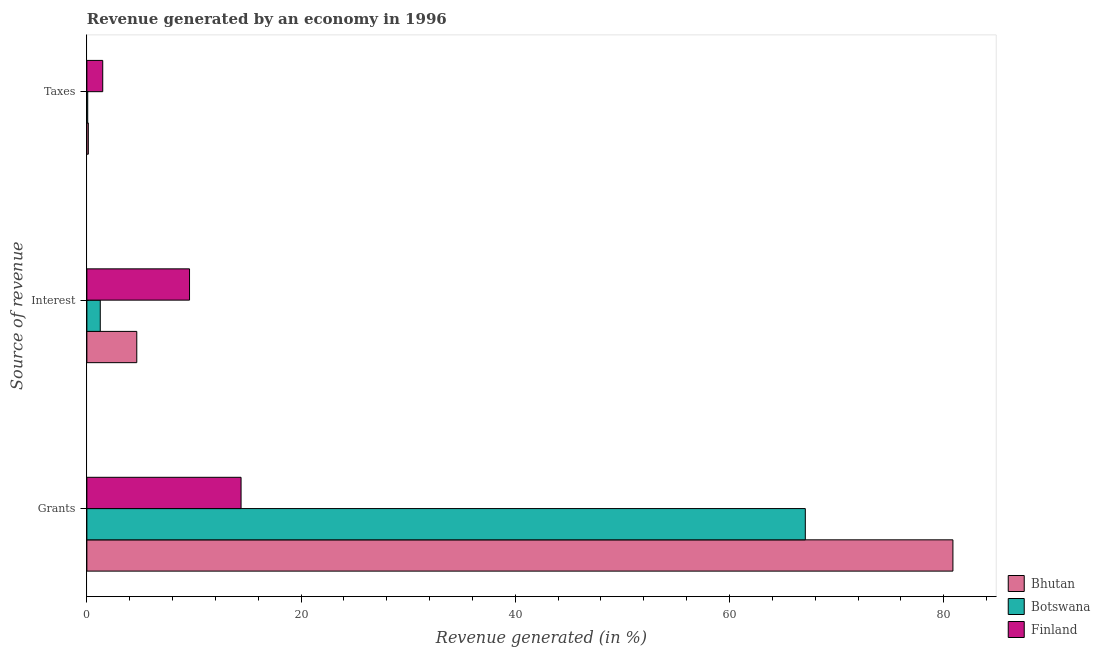How many different coloured bars are there?
Provide a succinct answer. 3. How many groups of bars are there?
Provide a succinct answer. 3. Are the number of bars per tick equal to the number of legend labels?
Your answer should be compact. Yes. How many bars are there on the 3rd tick from the top?
Ensure brevity in your answer.  3. What is the label of the 1st group of bars from the top?
Provide a short and direct response. Taxes. What is the percentage of revenue generated by taxes in Bhutan?
Your response must be concise. 0.14. Across all countries, what is the maximum percentage of revenue generated by taxes?
Your answer should be very brief. 1.48. Across all countries, what is the minimum percentage of revenue generated by taxes?
Provide a short and direct response. 0.08. In which country was the percentage of revenue generated by interest minimum?
Your answer should be compact. Botswana. What is the total percentage of revenue generated by grants in the graph?
Provide a succinct answer. 162.33. What is the difference between the percentage of revenue generated by interest in Finland and that in Bhutan?
Your answer should be compact. 4.92. What is the difference between the percentage of revenue generated by interest in Bhutan and the percentage of revenue generated by taxes in Finland?
Your response must be concise. 3.18. What is the average percentage of revenue generated by grants per country?
Your answer should be compact. 54.11. What is the difference between the percentage of revenue generated by taxes and percentage of revenue generated by grants in Bhutan?
Ensure brevity in your answer.  -80.72. In how many countries, is the percentage of revenue generated by grants greater than 36 %?
Provide a short and direct response. 2. What is the ratio of the percentage of revenue generated by taxes in Finland to that in Bhutan?
Give a very brief answer. 10.89. Is the percentage of revenue generated by interest in Finland less than that in Botswana?
Your response must be concise. No. Is the difference between the percentage of revenue generated by taxes in Bhutan and Finland greater than the difference between the percentage of revenue generated by grants in Bhutan and Finland?
Give a very brief answer. No. What is the difference between the highest and the second highest percentage of revenue generated by interest?
Provide a succinct answer. 4.92. What is the difference between the highest and the lowest percentage of revenue generated by interest?
Keep it short and to the point. 8.33. Is the sum of the percentage of revenue generated by taxes in Finland and Botswana greater than the maximum percentage of revenue generated by grants across all countries?
Your response must be concise. No. What does the 3rd bar from the top in Interest represents?
Offer a very short reply. Bhutan. What does the 3rd bar from the bottom in Taxes represents?
Keep it short and to the point. Finland. How many bars are there?
Your answer should be very brief. 9. Are all the bars in the graph horizontal?
Provide a succinct answer. Yes. How many countries are there in the graph?
Ensure brevity in your answer.  3. Does the graph contain any zero values?
Offer a very short reply. No. How many legend labels are there?
Your answer should be compact. 3. How are the legend labels stacked?
Keep it short and to the point. Vertical. What is the title of the graph?
Your answer should be compact. Revenue generated by an economy in 1996. Does "Least developed countries" appear as one of the legend labels in the graph?
Your answer should be compact. No. What is the label or title of the X-axis?
Provide a short and direct response. Revenue generated (in %). What is the label or title of the Y-axis?
Provide a succinct answer. Source of revenue. What is the Revenue generated (in %) in Bhutan in Grants?
Your answer should be very brief. 80.86. What is the Revenue generated (in %) in Botswana in Grants?
Your response must be concise. 67.08. What is the Revenue generated (in %) of Finland in Grants?
Your response must be concise. 14.4. What is the Revenue generated (in %) of Bhutan in Interest?
Offer a terse response. 4.66. What is the Revenue generated (in %) of Botswana in Interest?
Provide a succinct answer. 1.25. What is the Revenue generated (in %) in Finland in Interest?
Offer a terse response. 9.58. What is the Revenue generated (in %) of Bhutan in Taxes?
Provide a short and direct response. 0.14. What is the Revenue generated (in %) in Botswana in Taxes?
Provide a succinct answer. 0.08. What is the Revenue generated (in %) of Finland in Taxes?
Your answer should be very brief. 1.48. Across all Source of revenue, what is the maximum Revenue generated (in %) of Bhutan?
Provide a succinct answer. 80.86. Across all Source of revenue, what is the maximum Revenue generated (in %) in Botswana?
Give a very brief answer. 67.08. Across all Source of revenue, what is the maximum Revenue generated (in %) of Finland?
Your answer should be very brief. 14.4. Across all Source of revenue, what is the minimum Revenue generated (in %) in Bhutan?
Give a very brief answer. 0.14. Across all Source of revenue, what is the minimum Revenue generated (in %) of Botswana?
Your response must be concise. 0.08. Across all Source of revenue, what is the minimum Revenue generated (in %) in Finland?
Give a very brief answer. 1.48. What is the total Revenue generated (in %) in Bhutan in the graph?
Provide a short and direct response. 85.65. What is the total Revenue generated (in %) in Botswana in the graph?
Ensure brevity in your answer.  68.4. What is the total Revenue generated (in %) of Finland in the graph?
Give a very brief answer. 25.46. What is the difference between the Revenue generated (in %) in Bhutan in Grants and that in Interest?
Keep it short and to the point. 76.2. What is the difference between the Revenue generated (in %) in Botswana in Grants and that in Interest?
Keep it short and to the point. 65.83. What is the difference between the Revenue generated (in %) in Finland in Grants and that in Interest?
Provide a short and direct response. 4.81. What is the difference between the Revenue generated (in %) in Bhutan in Grants and that in Taxes?
Offer a very short reply. 80.72. What is the difference between the Revenue generated (in %) in Botswana in Grants and that in Taxes?
Offer a very short reply. 67. What is the difference between the Revenue generated (in %) in Finland in Grants and that in Taxes?
Offer a very short reply. 12.91. What is the difference between the Revenue generated (in %) in Bhutan in Interest and that in Taxes?
Make the answer very short. 4.52. What is the difference between the Revenue generated (in %) of Botswana in Interest and that in Taxes?
Offer a terse response. 1.17. What is the difference between the Revenue generated (in %) of Finland in Interest and that in Taxes?
Offer a very short reply. 8.1. What is the difference between the Revenue generated (in %) of Bhutan in Grants and the Revenue generated (in %) of Botswana in Interest?
Offer a very short reply. 79.61. What is the difference between the Revenue generated (in %) of Bhutan in Grants and the Revenue generated (in %) of Finland in Interest?
Your answer should be compact. 71.27. What is the difference between the Revenue generated (in %) in Botswana in Grants and the Revenue generated (in %) in Finland in Interest?
Ensure brevity in your answer.  57.49. What is the difference between the Revenue generated (in %) of Bhutan in Grants and the Revenue generated (in %) of Botswana in Taxes?
Keep it short and to the point. 80.78. What is the difference between the Revenue generated (in %) of Bhutan in Grants and the Revenue generated (in %) of Finland in Taxes?
Ensure brevity in your answer.  79.38. What is the difference between the Revenue generated (in %) of Botswana in Grants and the Revenue generated (in %) of Finland in Taxes?
Ensure brevity in your answer.  65.6. What is the difference between the Revenue generated (in %) in Bhutan in Interest and the Revenue generated (in %) in Botswana in Taxes?
Your answer should be compact. 4.58. What is the difference between the Revenue generated (in %) in Bhutan in Interest and the Revenue generated (in %) in Finland in Taxes?
Keep it short and to the point. 3.18. What is the difference between the Revenue generated (in %) of Botswana in Interest and the Revenue generated (in %) of Finland in Taxes?
Offer a very short reply. -0.23. What is the average Revenue generated (in %) in Bhutan per Source of revenue?
Make the answer very short. 28.55. What is the average Revenue generated (in %) of Botswana per Source of revenue?
Your response must be concise. 22.8. What is the average Revenue generated (in %) of Finland per Source of revenue?
Make the answer very short. 8.49. What is the difference between the Revenue generated (in %) in Bhutan and Revenue generated (in %) in Botswana in Grants?
Ensure brevity in your answer.  13.78. What is the difference between the Revenue generated (in %) in Bhutan and Revenue generated (in %) in Finland in Grants?
Your answer should be very brief. 66.46. What is the difference between the Revenue generated (in %) of Botswana and Revenue generated (in %) of Finland in Grants?
Make the answer very short. 52.68. What is the difference between the Revenue generated (in %) of Bhutan and Revenue generated (in %) of Botswana in Interest?
Ensure brevity in your answer.  3.41. What is the difference between the Revenue generated (in %) in Bhutan and Revenue generated (in %) in Finland in Interest?
Make the answer very short. -4.92. What is the difference between the Revenue generated (in %) in Botswana and Revenue generated (in %) in Finland in Interest?
Your answer should be compact. -8.33. What is the difference between the Revenue generated (in %) in Bhutan and Revenue generated (in %) in Botswana in Taxes?
Provide a succinct answer. 0.06. What is the difference between the Revenue generated (in %) in Bhutan and Revenue generated (in %) in Finland in Taxes?
Make the answer very short. -1.34. What is the difference between the Revenue generated (in %) of Botswana and Revenue generated (in %) of Finland in Taxes?
Your response must be concise. -1.4. What is the ratio of the Revenue generated (in %) in Bhutan in Grants to that in Interest?
Offer a very short reply. 17.35. What is the ratio of the Revenue generated (in %) of Botswana in Grants to that in Interest?
Make the answer very short. 53.65. What is the ratio of the Revenue generated (in %) of Finland in Grants to that in Interest?
Make the answer very short. 1.5. What is the ratio of the Revenue generated (in %) in Bhutan in Grants to that in Taxes?
Make the answer very short. 594.35. What is the ratio of the Revenue generated (in %) in Botswana in Grants to that in Taxes?
Keep it short and to the point. 860.35. What is the ratio of the Revenue generated (in %) of Finland in Grants to that in Taxes?
Ensure brevity in your answer.  9.72. What is the ratio of the Revenue generated (in %) of Bhutan in Interest to that in Taxes?
Offer a terse response. 34.25. What is the ratio of the Revenue generated (in %) of Botswana in Interest to that in Taxes?
Make the answer very short. 16.04. What is the ratio of the Revenue generated (in %) in Finland in Interest to that in Taxes?
Your answer should be compact. 6.47. What is the difference between the highest and the second highest Revenue generated (in %) in Bhutan?
Give a very brief answer. 76.2. What is the difference between the highest and the second highest Revenue generated (in %) in Botswana?
Offer a terse response. 65.83. What is the difference between the highest and the second highest Revenue generated (in %) in Finland?
Make the answer very short. 4.81. What is the difference between the highest and the lowest Revenue generated (in %) of Bhutan?
Provide a succinct answer. 80.72. What is the difference between the highest and the lowest Revenue generated (in %) in Botswana?
Give a very brief answer. 67. What is the difference between the highest and the lowest Revenue generated (in %) of Finland?
Your answer should be compact. 12.91. 